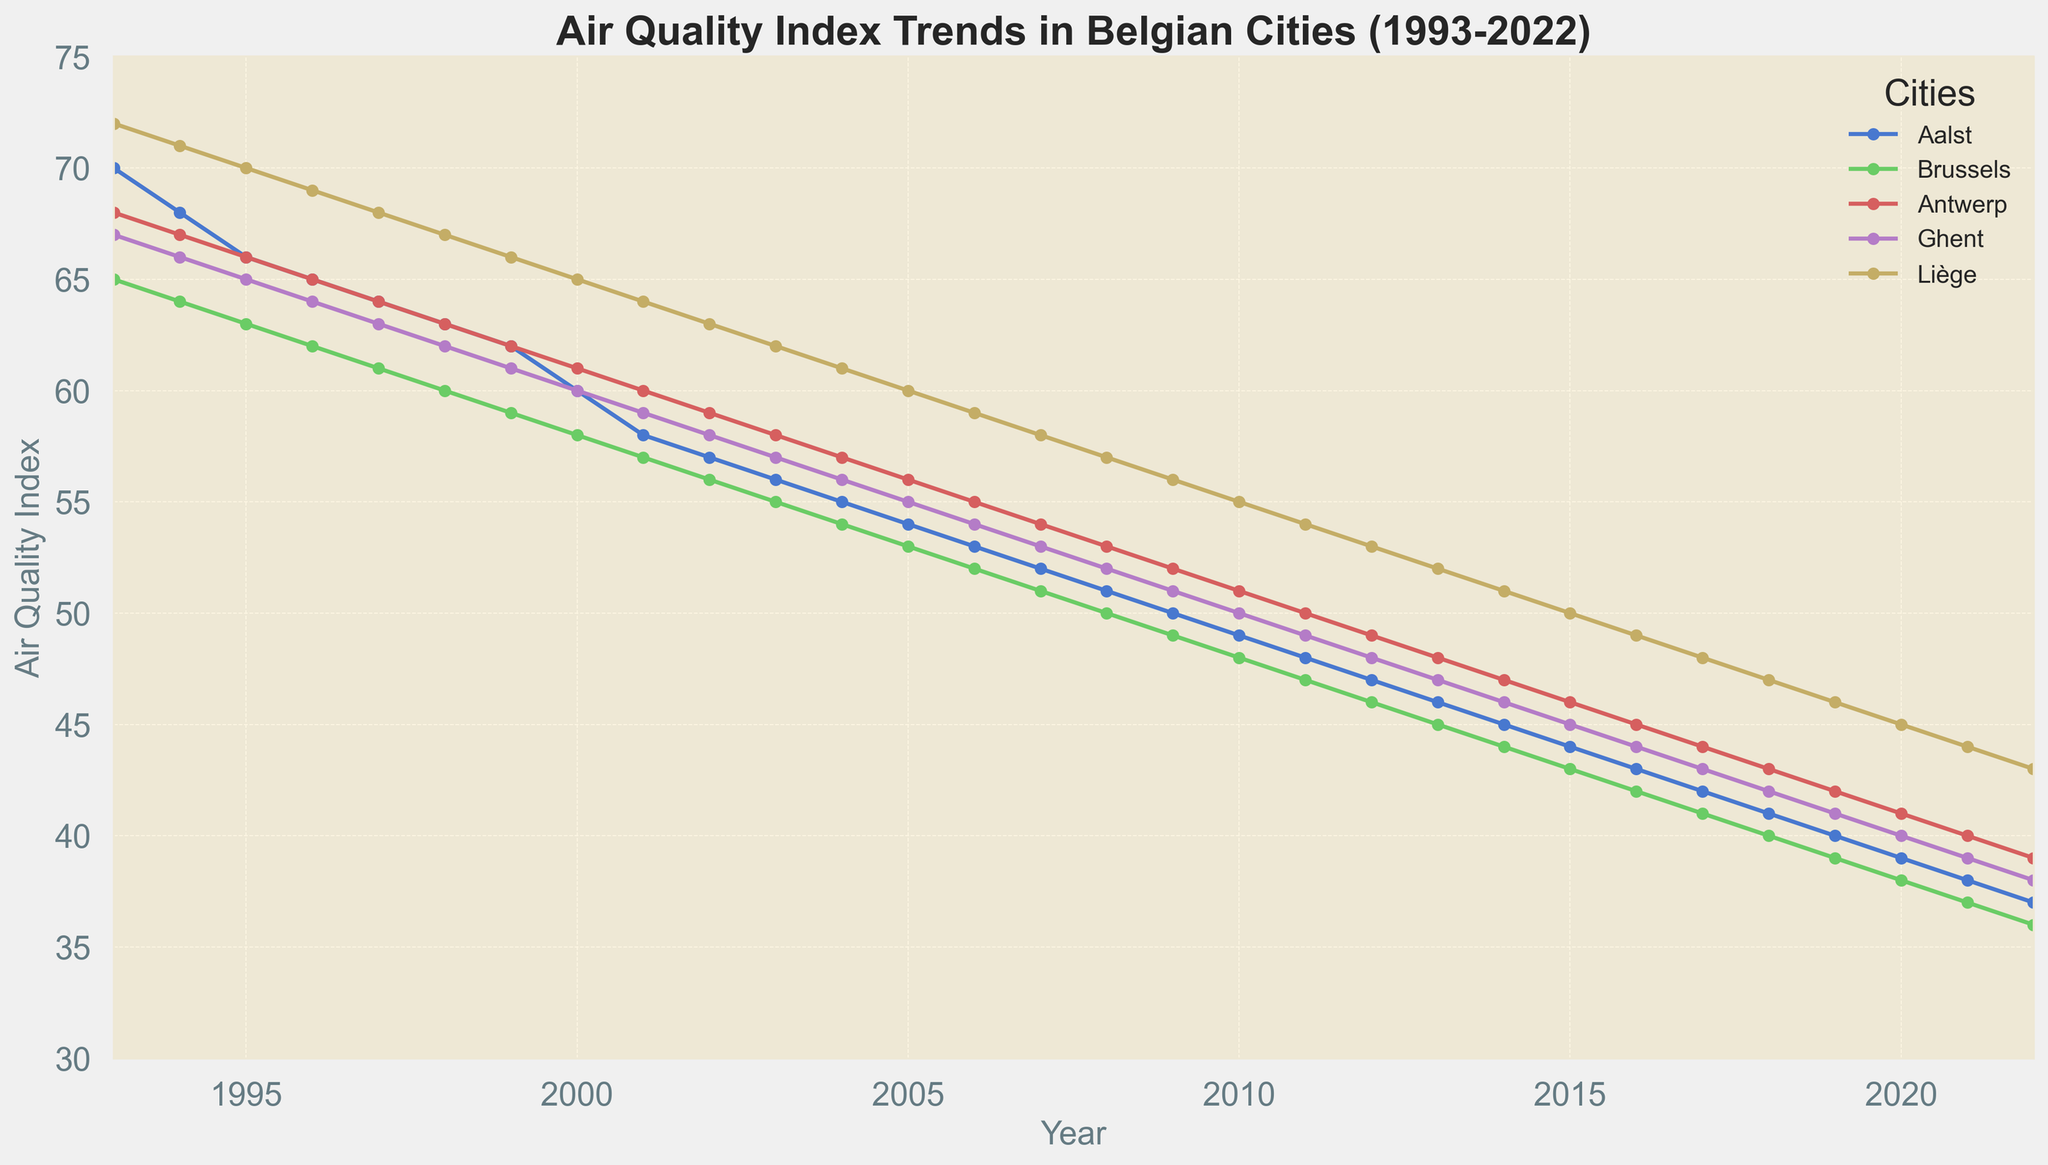Which city had the highest Air Quality Index in 1993? Look at the figures of the Air Quality Index for all cities in 1993. Brussels had 65, Antwerp had 68, Ghent had 67, and Liège had 72; Aalst had 70. Liège's index of 72 was the highest.
Answer: Liège In which year did Aalst's Air Quality Index drop below 50? Follow the trend line for Aalst and see where the index goes below 50. It first dropped below 50 in 2009.
Answer: 2009 How has the Air Quality Index in Brussels changed from 1993 to 2022? Look at the Air Quality Index for Brussels in 1993 and compare it with the index in 2022. In 1993, it was 65, and in 2022, it was 36. The index has decreased over this period.
Answer: Decreased Which city showed the most significant improvement in Air Quality Index from 1993 to 2022? Calculate the difference between the 1993 and 2022 Air Quality Index for each city. Aalst improved from 70 to 37 (33 points), Brussels from 65 to 36 (29 points), Antwerp from 68 to 39 (29 points), Ghent from 67 to 38 (29 points), and Liège from 72 to 43 (29 points). Aalst shows the most significant improvement.
Answer: Aalst By how much did Ghent's Air Quality Index decrease from 2000 to 2020? Check Ghent's Air Quality Index in 2000 and 2020. In 2000, it was 60, and in 2020, it was 40. The decrease is 60 - 40 = 20 points.
Answer: 20 points Which city had a better Air Quality Index in 2022: Antwerp or Brussels? Compare the Air Quality Index of Antwerp and Brussels in 2022. Antwerp had 39, and Brussels had 36. Brussels had a better (lower) index.
Answer: Brussels Was Aalst's Air Quality Index ever lower than Liège's during the 30-year period? Compare their indices year by year to see if Aalst's index was ever lower than Liège's. Starting from 1996, Aalst's index was consistently lower. Therefore, yes, it was lower.
Answer: Yes What's the average Air Quality Index for Antwerp from 1993 to 1995? Sum the Air Quality Index values for Antwerp from 1993, 1994, and 1995, then divide by 3: (68 + 67 + 66) / 3 = 201 / 3. The average is 67.
Answer: 67 How did the Air Quality Index trend differ between Aalst and Liège from 1993 to 2022? Observe the trends for both cities. Aalst's index consistently decreased from 70 to 37, while Liège's also decreased but started higher at 72 and ended at 43. Both cities showed a downward trend.
Answer: Aalst and Liège both decreased 